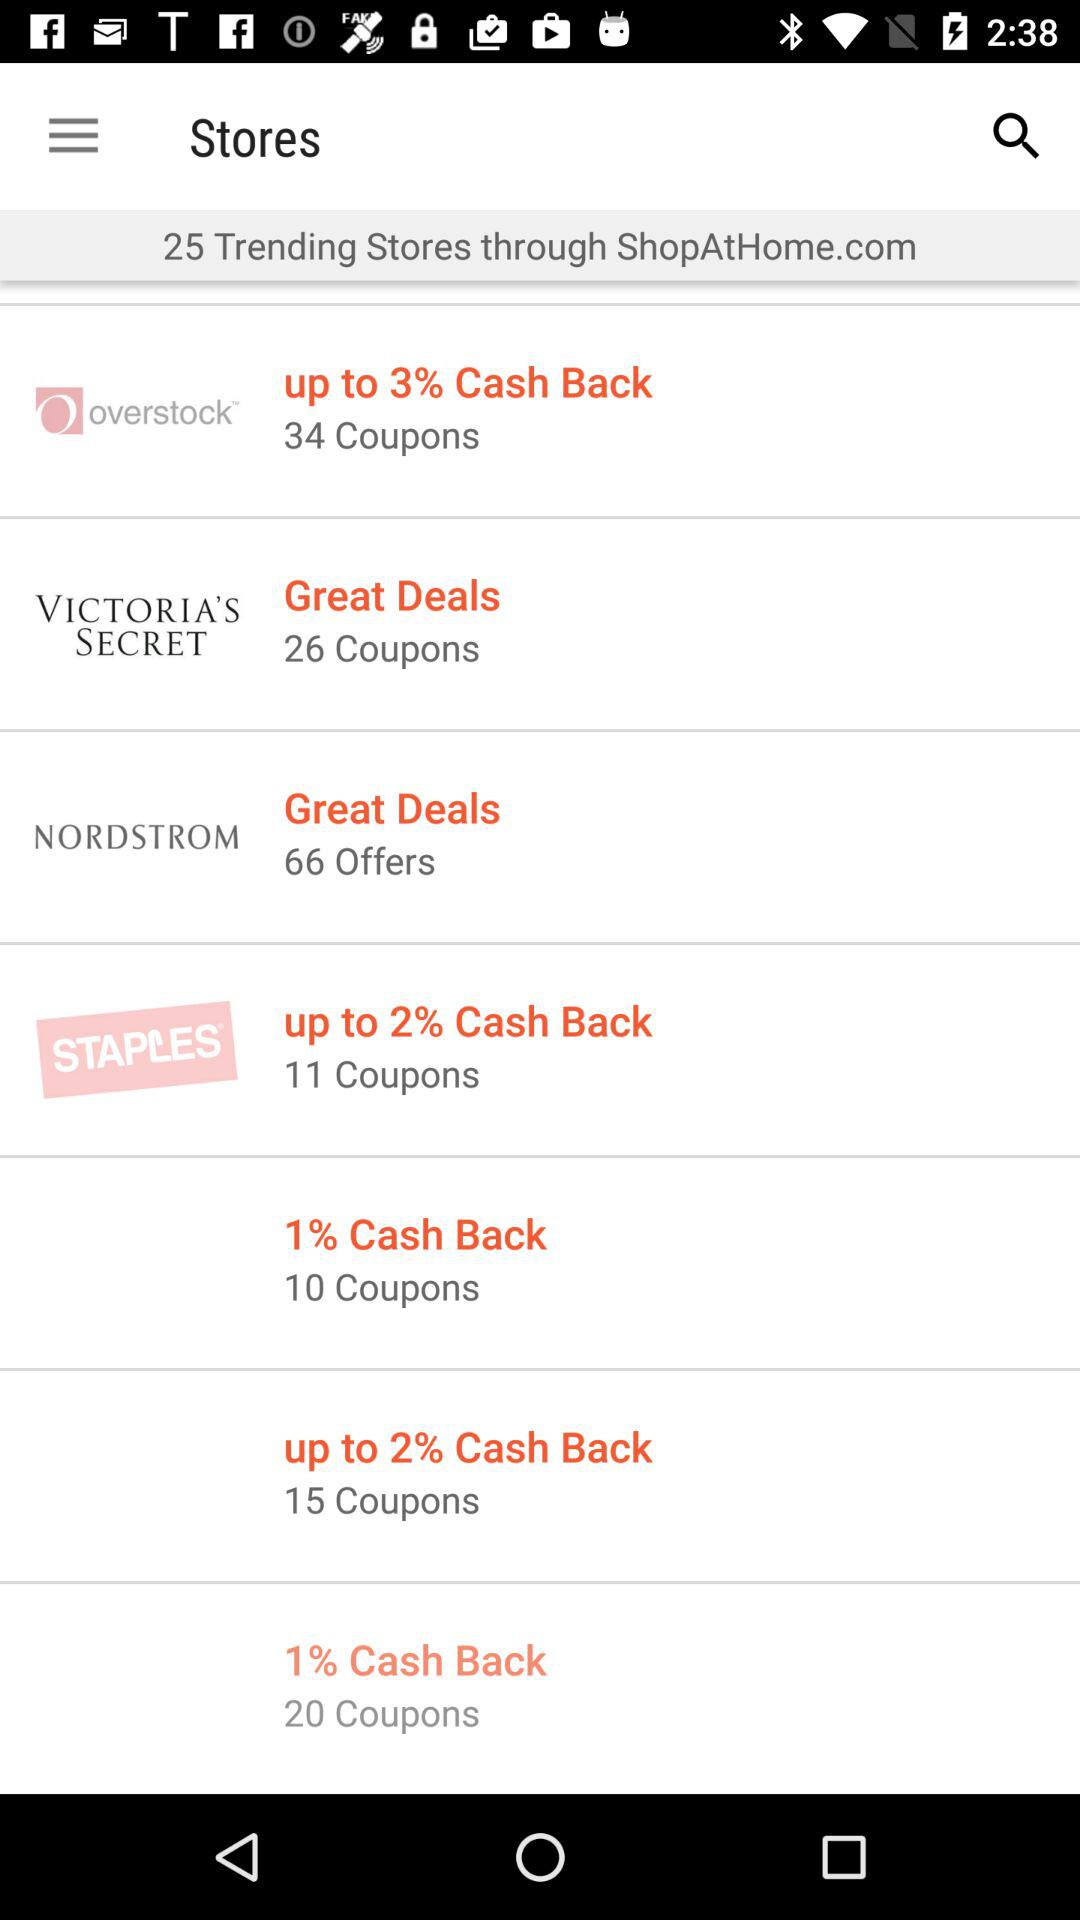How many offers are for "NORDSTROM"? There are 66 offers for "NORDSTROM". 